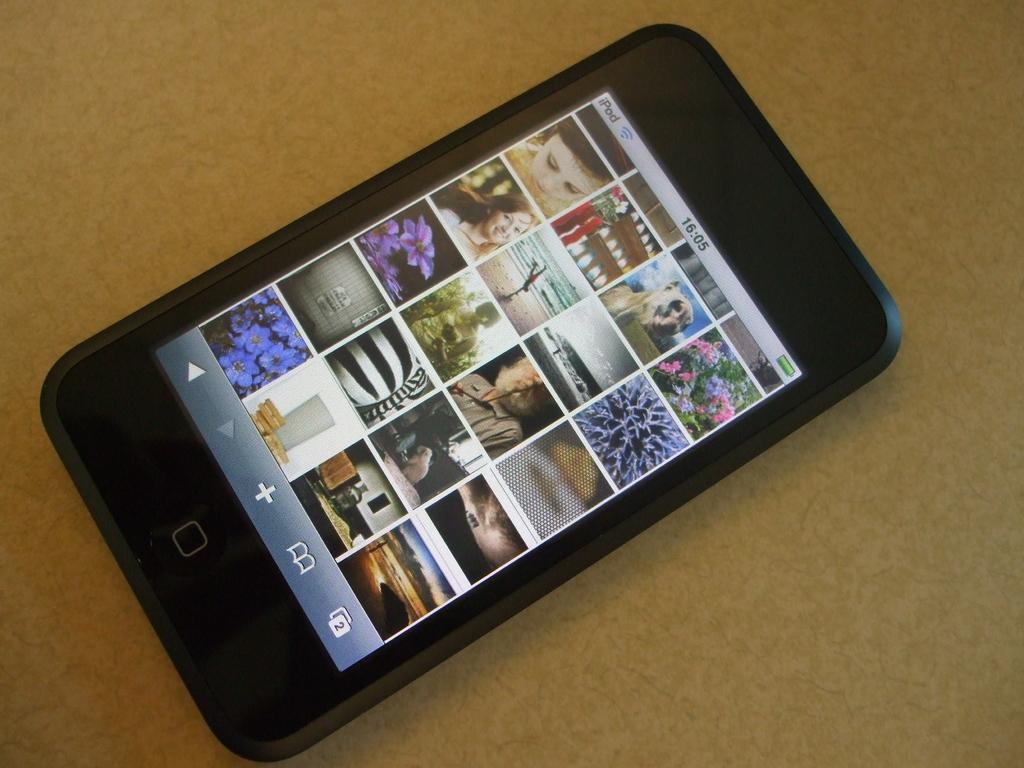How would you summarize this image in a sentence or two? In the center of the picture there is an iPhone on a surface. In the iPhone there are pictures of persons, plants, trees and many other objects. 